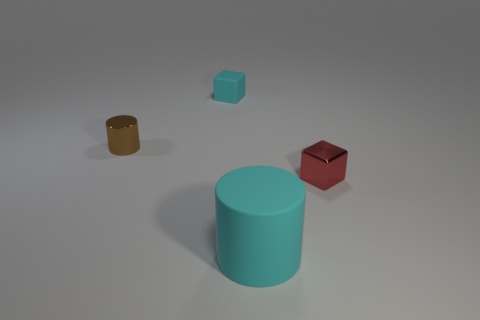Add 1 cyan objects. How many objects exist? 5 Add 3 matte cylinders. How many matte cylinders are left? 4 Add 2 brown matte cylinders. How many brown matte cylinders exist? 2 Subtract 0 blue cubes. How many objects are left? 4 Subtract all small blue matte things. Subtract all cyan things. How many objects are left? 2 